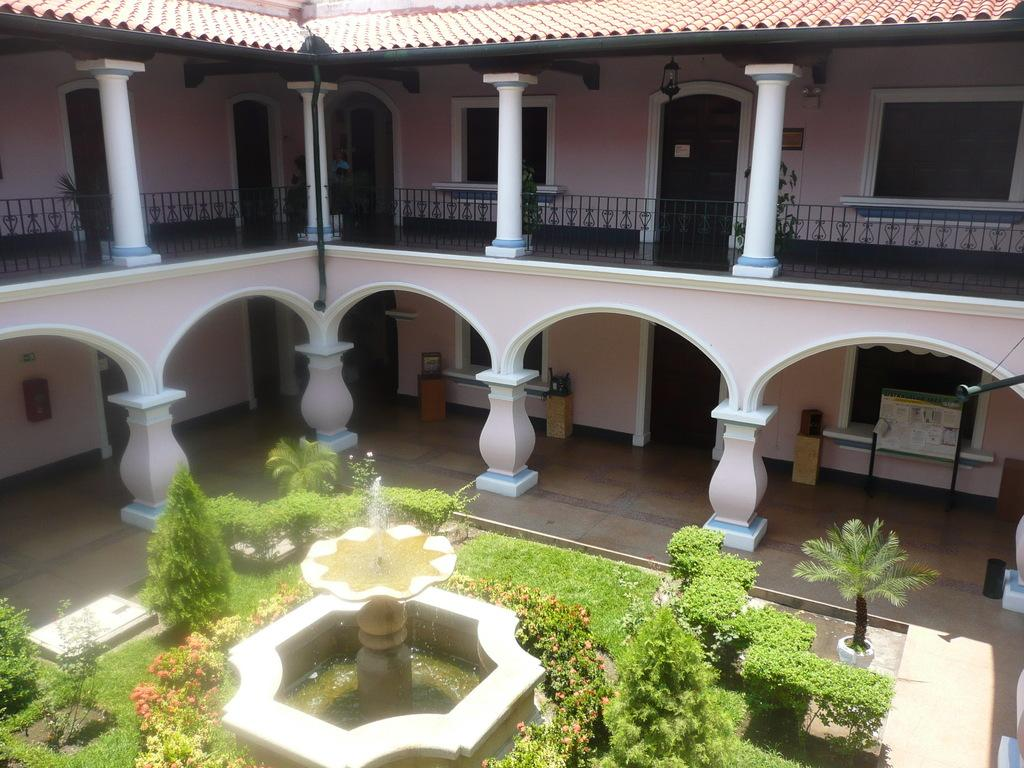What type of structure is visible in the image? There is a building in the image. What natural feature is present in the image? There is a waterfall in the image. What type of vegetation can be seen around the building and waterfall? There are plants around the building and waterfall. Where is the scarecrow located in the image? There is no scarecrow present in the image. What type of education is being offered at the building in the image? The image does not provide information about the type of education being offered at the building. 